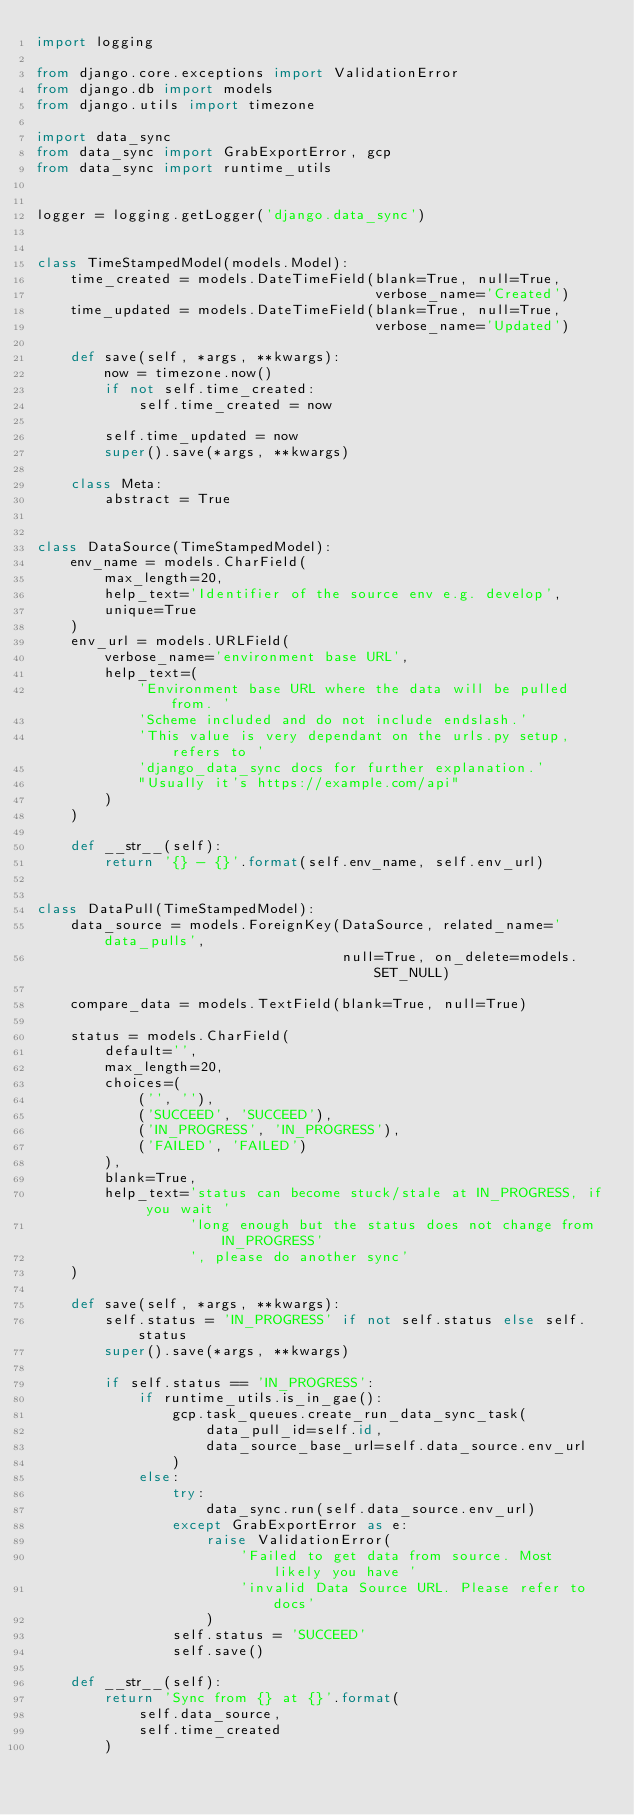<code> <loc_0><loc_0><loc_500><loc_500><_Python_>import logging

from django.core.exceptions import ValidationError
from django.db import models
from django.utils import timezone

import data_sync
from data_sync import GrabExportError, gcp
from data_sync import runtime_utils


logger = logging.getLogger('django.data_sync')


class TimeStampedModel(models.Model):
    time_created = models.DateTimeField(blank=True, null=True,
                                        verbose_name='Created')
    time_updated = models.DateTimeField(blank=True, null=True,
                                        verbose_name='Updated')

    def save(self, *args, **kwargs):
        now = timezone.now()
        if not self.time_created:
            self.time_created = now

        self.time_updated = now
        super().save(*args, **kwargs)

    class Meta:
        abstract = True


class DataSource(TimeStampedModel):
    env_name = models.CharField(
        max_length=20,
        help_text='Identifier of the source env e.g. develop',
        unique=True
    )
    env_url = models.URLField(
        verbose_name='environment base URL',
        help_text=(
            'Environment base URL where the data will be pulled from. '
            'Scheme included and do not include endslash.'
            'This value is very dependant on the urls.py setup, refers to '
            'django_data_sync docs for further explanation.'
            "Usually it's https://example.com/api"
        )
    )

    def __str__(self):
        return '{} - {}'.format(self.env_name, self.env_url)


class DataPull(TimeStampedModel):
    data_source = models.ForeignKey(DataSource, related_name='data_pulls',
                                    null=True, on_delete=models.SET_NULL)

    compare_data = models.TextField(blank=True, null=True)

    status = models.CharField(
        default='',
        max_length=20,
        choices=(
            ('', ''),
            ('SUCCEED', 'SUCCEED'),
            ('IN_PROGRESS', 'IN_PROGRESS'),
            ('FAILED', 'FAILED')
        ),
        blank=True,
        help_text='status can become stuck/stale at IN_PROGRESS, if you wait '
                  'long enough but the status does not change from IN_PROGRESS'
                  ', please do another sync'
    )

    def save(self, *args, **kwargs):
        self.status = 'IN_PROGRESS' if not self.status else self.status
        super().save(*args, **kwargs)

        if self.status == 'IN_PROGRESS':
            if runtime_utils.is_in_gae():
                gcp.task_queues.create_run_data_sync_task(
                    data_pull_id=self.id,
                    data_source_base_url=self.data_source.env_url
                )
            else:
                try:
                    data_sync.run(self.data_source.env_url)
                except GrabExportError as e:
                    raise ValidationError(
                        'Failed to get data from source. Most likely you have '
                        'invalid Data Source URL. Please refer to docs'
                    )
                self.status = 'SUCCEED'
                self.save()

    def __str__(self):
        return 'Sync from {} at {}'.format(
            self.data_source,
            self.time_created
        )
</code> 